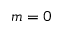Convert formula to latex. <formula><loc_0><loc_0><loc_500><loc_500>m = 0</formula> 